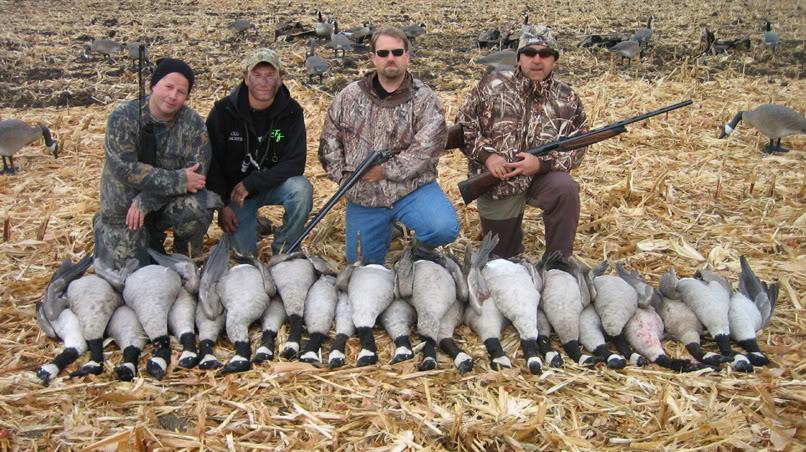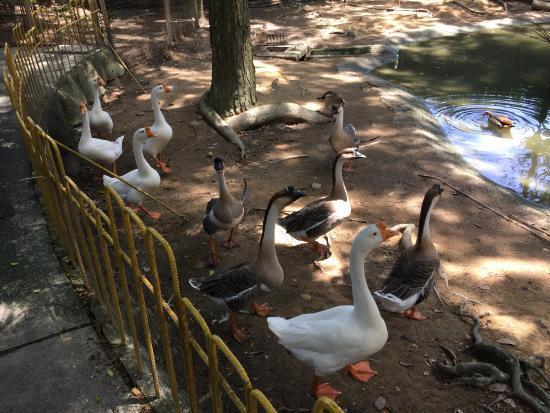The first image is the image on the left, the second image is the image on the right. For the images shown, is this caption "There are exactly four people in the image on the left." true? Answer yes or no. Yes. 